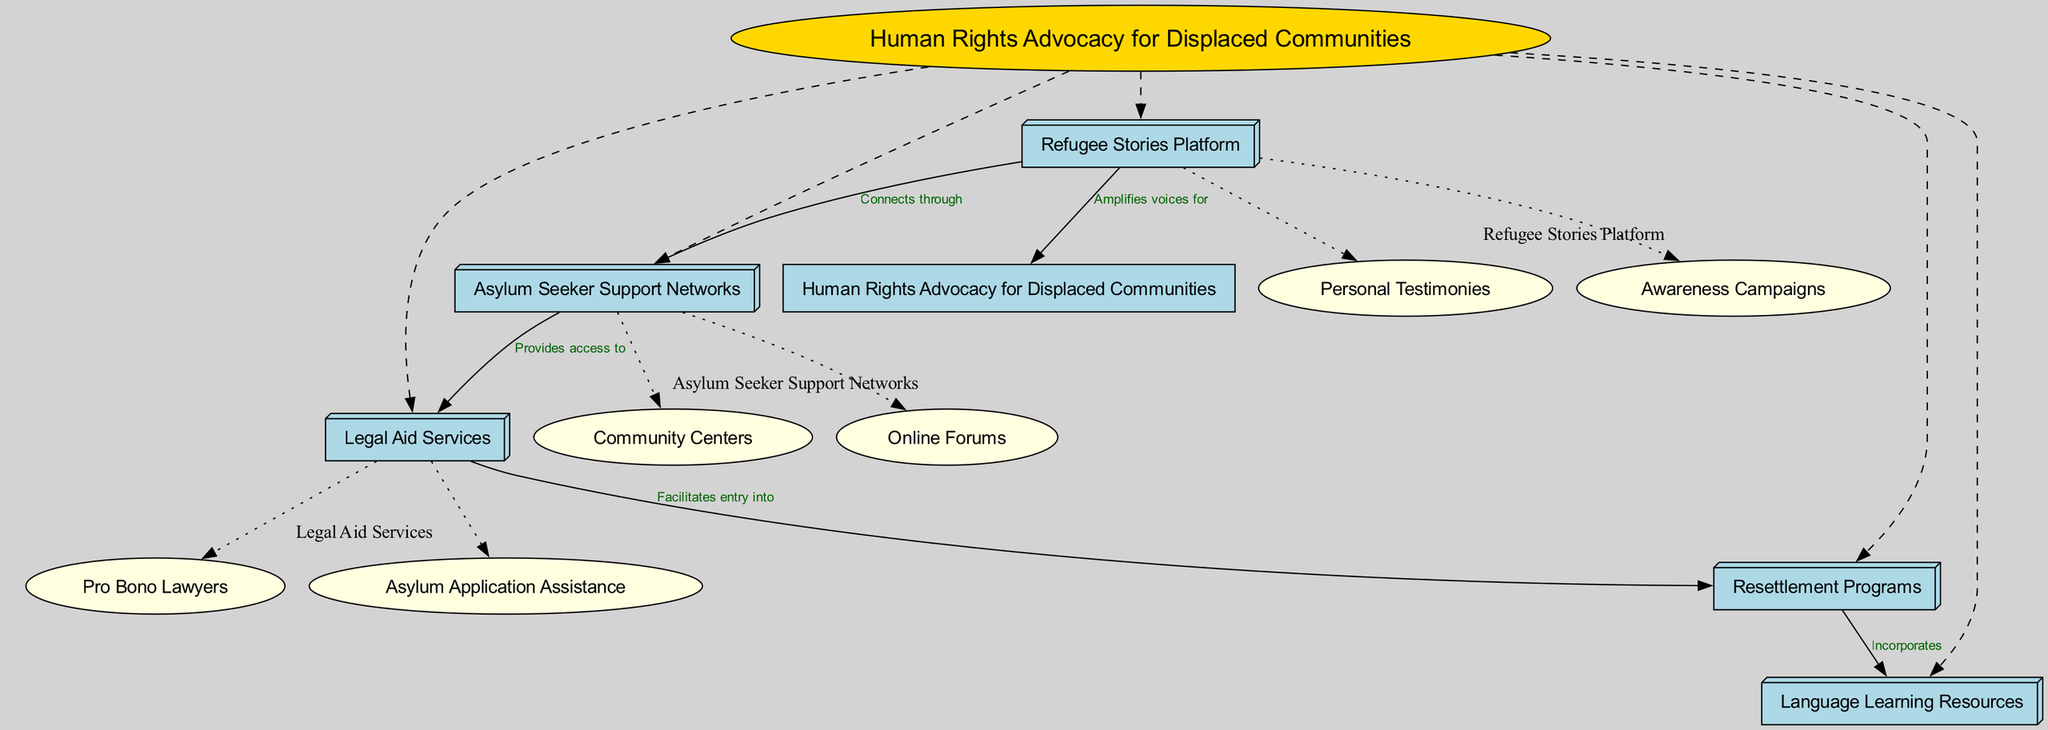What is the central concept of the diagram? The central concept node is labeled as "Human Rights Advocacy for Displaced Communities." This is found at the center of the diagram, distinguishing the main area of focus.
Answer: Human Rights Advocacy for Displaced Communities How many main nodes are there? The main nodes are five in total: "Asylum Seeker Support Networks," "Legal Aid Services," "Refugee Stories Platform," "Resettlement Programs," and "Language Learning Resources." Counting these nodes gives the answer.
Answer: 5 What connects "Asylum Seeker Support Networks" and "Legal Aid Services"? The connection is labeled "Provides access to," indicating the relationship between these two nodes. This can be traced along the edge connecting them.
Answer: Provides access to Which resources does "Resettlement Programs" incorporate? The sub-node labeled "Language Learning Resources" is connected to "Resettlement Programs" with the label "Incorporates." This indicates that these resources are part of the programs.
Answer: Language Learning Resources What is the purpose of the "Refugee Stories Platform"? It serves to "Amplifies voices for" human rights advocacy as per its connection to the central concept, which reflects its role in the overall diagram. This can be seen directly from the edge connecting it to the central concept.
Answer: Amplifies voices for Which sub-nodes belong to "Asylum Seeker Support Networks"? The sub-nodes are "Community Centers" and "Online Forums," which are children of this parent node. These can be identified within the cluster that identifies the parent node.
Answer: Community Centers, Online Forums What type of services do "Legal Aid Services" provide? They provide "Pro Bono Lawyers" and "Asylum Application Assistance," which are both children of this node and represent specific types of legal aid available to displaced individuals.
Answer: Pro Bono Lawyers, Asylum Application Assistance What connects "Refugee Stories Platform" to "Asylum Seeker Support Networks"? The connection is labeled "Connects through," illustrating how these two nodes are related within the advocacy framework shown in the diagram.
Answer: Connects through 